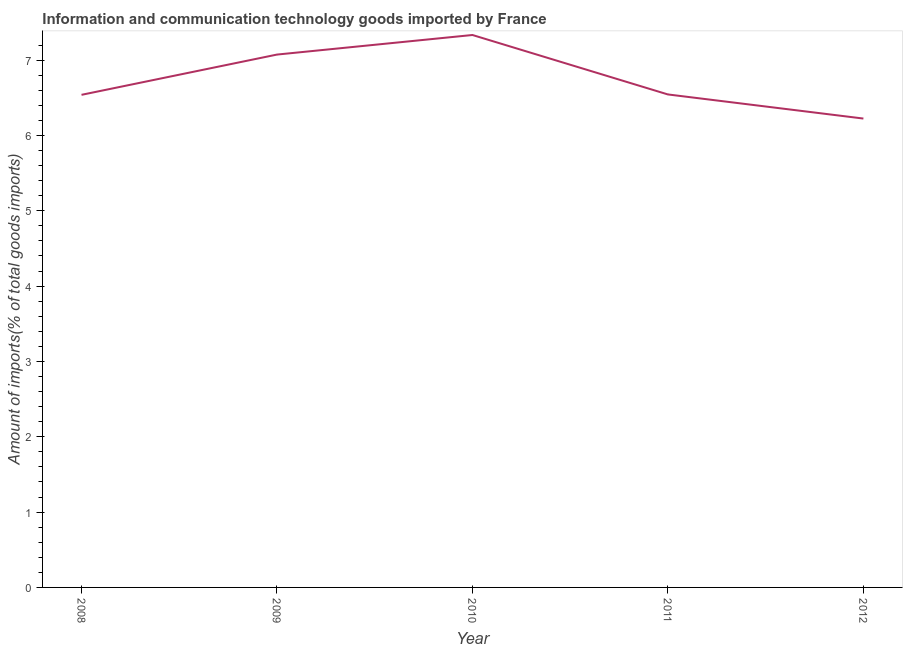What is the amount of ict goods imports in 2011?
Keep it short and to the point. 6.54. Across all years, what is the maximum amount of ict goods imports?
Provide a short and direct response. 7.33. Across all years, what is the minimum amount of ict goods imports?
Provide a succinct answer. 6.22. What is the sum of the amount of ict goods imports?
Provide a short and direct response. 33.71. What is the difference between the amount of ict goods imports in 2008 and 2009?
Keep it short and to the point. -0.53. What is the average amount of ict goods imports per year?
Ensure brevity in your answer.  6.74. What is the median amount of ict goods imports?
Ensure brevity in your answer.  6.54. In how many years, is the amount of ict goods imports greater than 3.4 %?
Provide a succinct answer. 5. What is the ratio of the amount of ict goods imports in 2008 to that in 2009?
Provide a short and direct response. 0.92. What is the difference between the highest and the second highest amount of ict goods imports?
Your answer should be very brief. 0.26. Is the sum of the amount of ict goods imports in 2009 and 2011 greater than the maximum amount of ict goods imports across all years?
Ensure brevity in your answer.  Yes. What is the difference between the highest and the lowest amount of ict goods imports?
Keep it short and to the point. 1.11. How many lines are there?
Offer a very short reply. 1. How many years are there in the graph?
Offer a very short reply. 5. Does the graph contain any zero values?
Keep it short and to the point. No. What is the title of the graph?
Ensure brevity in your answer.  Information and communication technology goods imported by France. What is the label or title of the Y-axis?
Ensure brevity in your answer.  Amount of imports(% of total goods imports). What is the Amount of imports(% of total goods imports) of 2008?
Offer a terse response. 6.54. What is the Amount of imports(% of total goods imports) in 2009?
Make the answer very short. 7.07. What is the Amount of imports(% of total goods imports) in 2010?
Your answer should be very brief. 7.33. What is the Amount of imports(% of total goods imports) of 2011?
Give a very brief answer. 6.54. What is the Amount of imports(% of total goods imports) in 2012?
Offer a very short reply. 6.22. What is the difference between the Amount of imports(% of total goods imports) in 2008 and 2009?
Offer a very short reply. -0.53. What is the difference between the Amount of imports(% of total goods imports) in 2008 and 2010?
Provide a short and direct response. -0.79. What is the difference between the Amount of imports(% of total goods imports) in 2008 and 2011?
Your answer should be very brief. -0. What is the difference between the Amount of imports(% of total goods imports) in 2008 and 2012?
Your response must be concise. 0.31. What is the difference between the Amount of imports(% of total goods imports) in 2009 and 2010?
Provide a succinct answer. -0.26. What is the difference between the Amount of imports(% of total goods imports) in 2009 and 2011?
Offer a terse response. 0.53. What is the difference between the Amount of imports(% of total goods imports) in 2009 and 2012?
Your answer should be compact. 0.85. What is the difference between the Amount of imports(% of total goods imports) in 2010 and 2011?
Provide a short and direct response. 0.79. What is the difference between the Amount of imports(% of total goods imports) in 2010 and 2012?
Give a very brief answer. 1.11. What is the difference between the Amount of imports(% of total goods imports) in 2011 and 2012?
Your answer should be very brief. 0.32. What is the ratio of the Amount of imports(% of total goods imports) in 2008 to that in 2009?
Ensure brevity in your answer.  0.92. What is the ratio of the Amount of imports(% of total goods imports) in 2008 to that in 2010?
Provide a short and direct response. 0.89. What is the ratio of the Amount of imports(% of total goods imports) in 2008 to that in 2012?
Offer a very short reply. 1.05. What is the ratio of the Amount of imports(% of total goods imports) in 2009 to that in 2011?
Your response must be concise. 1.08. What is the ratio of the Amount of imports(% of total goods imports) in 2009 to that in 2012?
Keep it short and to the point. 1.14. What is the ratio of the Amount of imports(% of total goods imports) in 2010 to that in 2011?
Give a very brief answer. 1.12. What is the ratio of the Amount of imports(% of total goods imports) in 2010 to that in 2012?
Offer a terse response. 1.18. What is the ratio of the Amount of imports(% of total goods imports) in 2011 to that in 2012?
Keep it short and to the point. 1.05. 